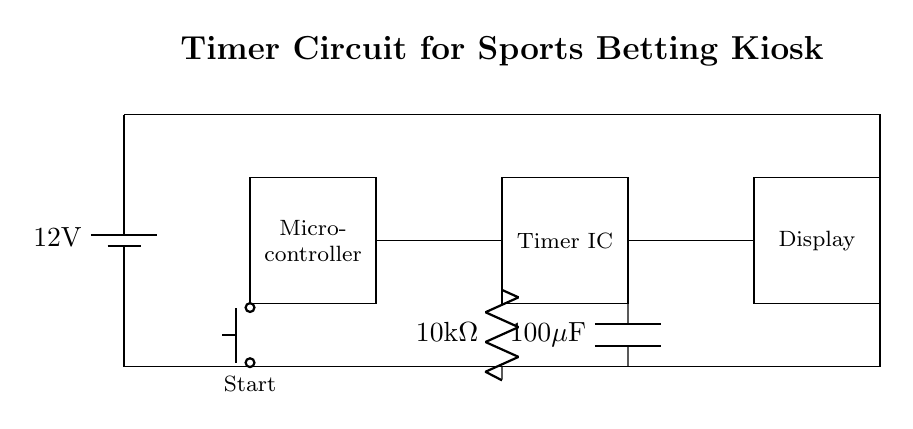What is the voltage of this circuit? The voltage is 12 volts, which is indicated by the battery symbol at the beginning of the circuit diagram.
Answer: 12 volts What is the function of the microcontroller? The microcontroller is responsible for controlling the timer and managing input from the start button, which is shown as a rectangle labeled 'Micro-controller' in the diagram.
Answer: Control What components are used for timing? The components used for timing are a resistor and a capacitor, labeled as 10k ohm and 100 microfarads respectively, which are shown connected to the Timer IC.
Answer: Resistor and Capacitor How is the Timer IC powered? The Timer IC is powered by a direct connection to the 12-volt supply line, shown by the vertical line running from the battery to the Timer IC.
Answer: 12 volts What does the push button do? The push button, labeled 'Start', initiates the timer function by sending a signal to the microcontroller when pressed, enabling the circuit to begin time tracking.
Answer: Start What is the purpose of the display? The display shows the countdown or time remaining, signified in the circuit by the labeled rectangle 'Display' connected to the Timer IC.
Answer: Display time 